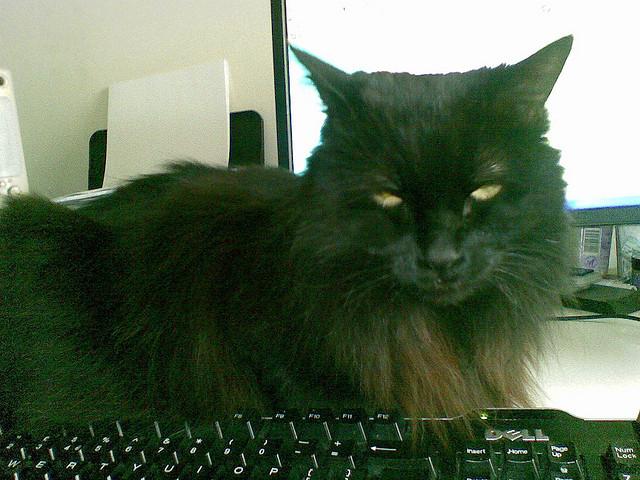What animal is this?
Concise answer only. Cat. What color is this?
Keep it brief. Black. What is the animal sitting near?
Write a very short answer. Keyboard. 